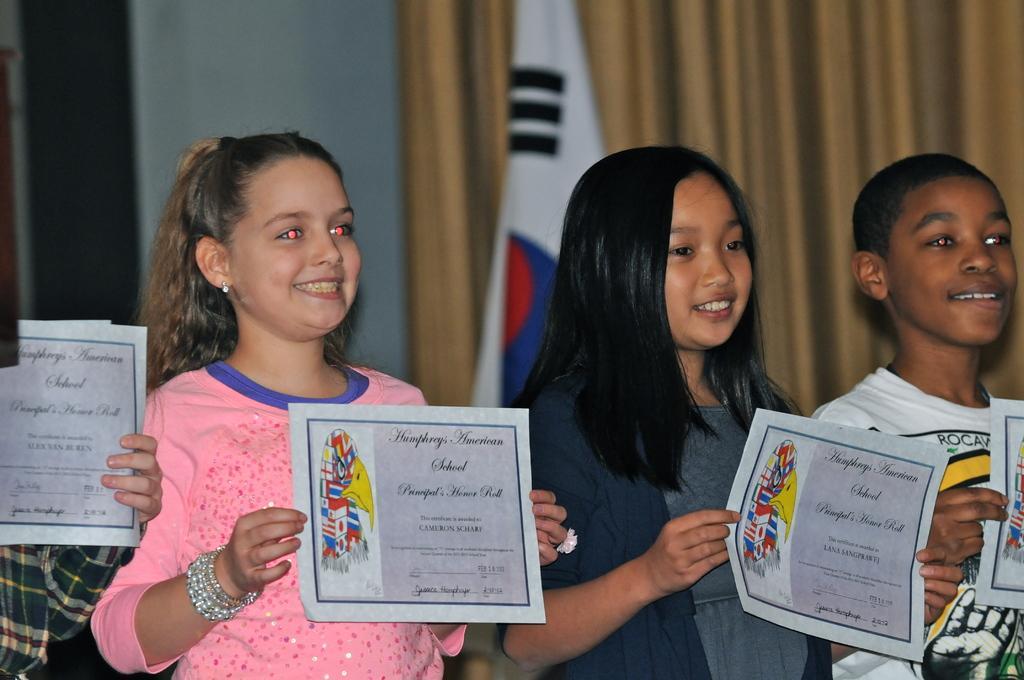In one or two sentences, can you explain what this image depicts? In this picture there are of people standing and smiling and holding the papers. At the back there is a flag, curtain and there is a wall. 